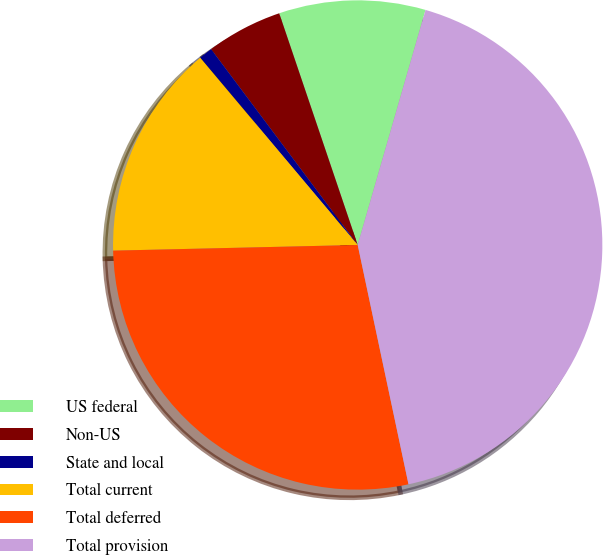<chart> <loc_0><loc_0><loc_500><loc_500><pie_chart><fcel>US federal<fcel>Non-US<fcel>State and local<fcel>Total current<fcel>Total deferred<fcel>Total provision<nl><fcel>9.67%<fcel>5.03%<fcel>0.9%<fcel>14.24%<fcel>27.96%<fcel>42.2%<nl></chart> 